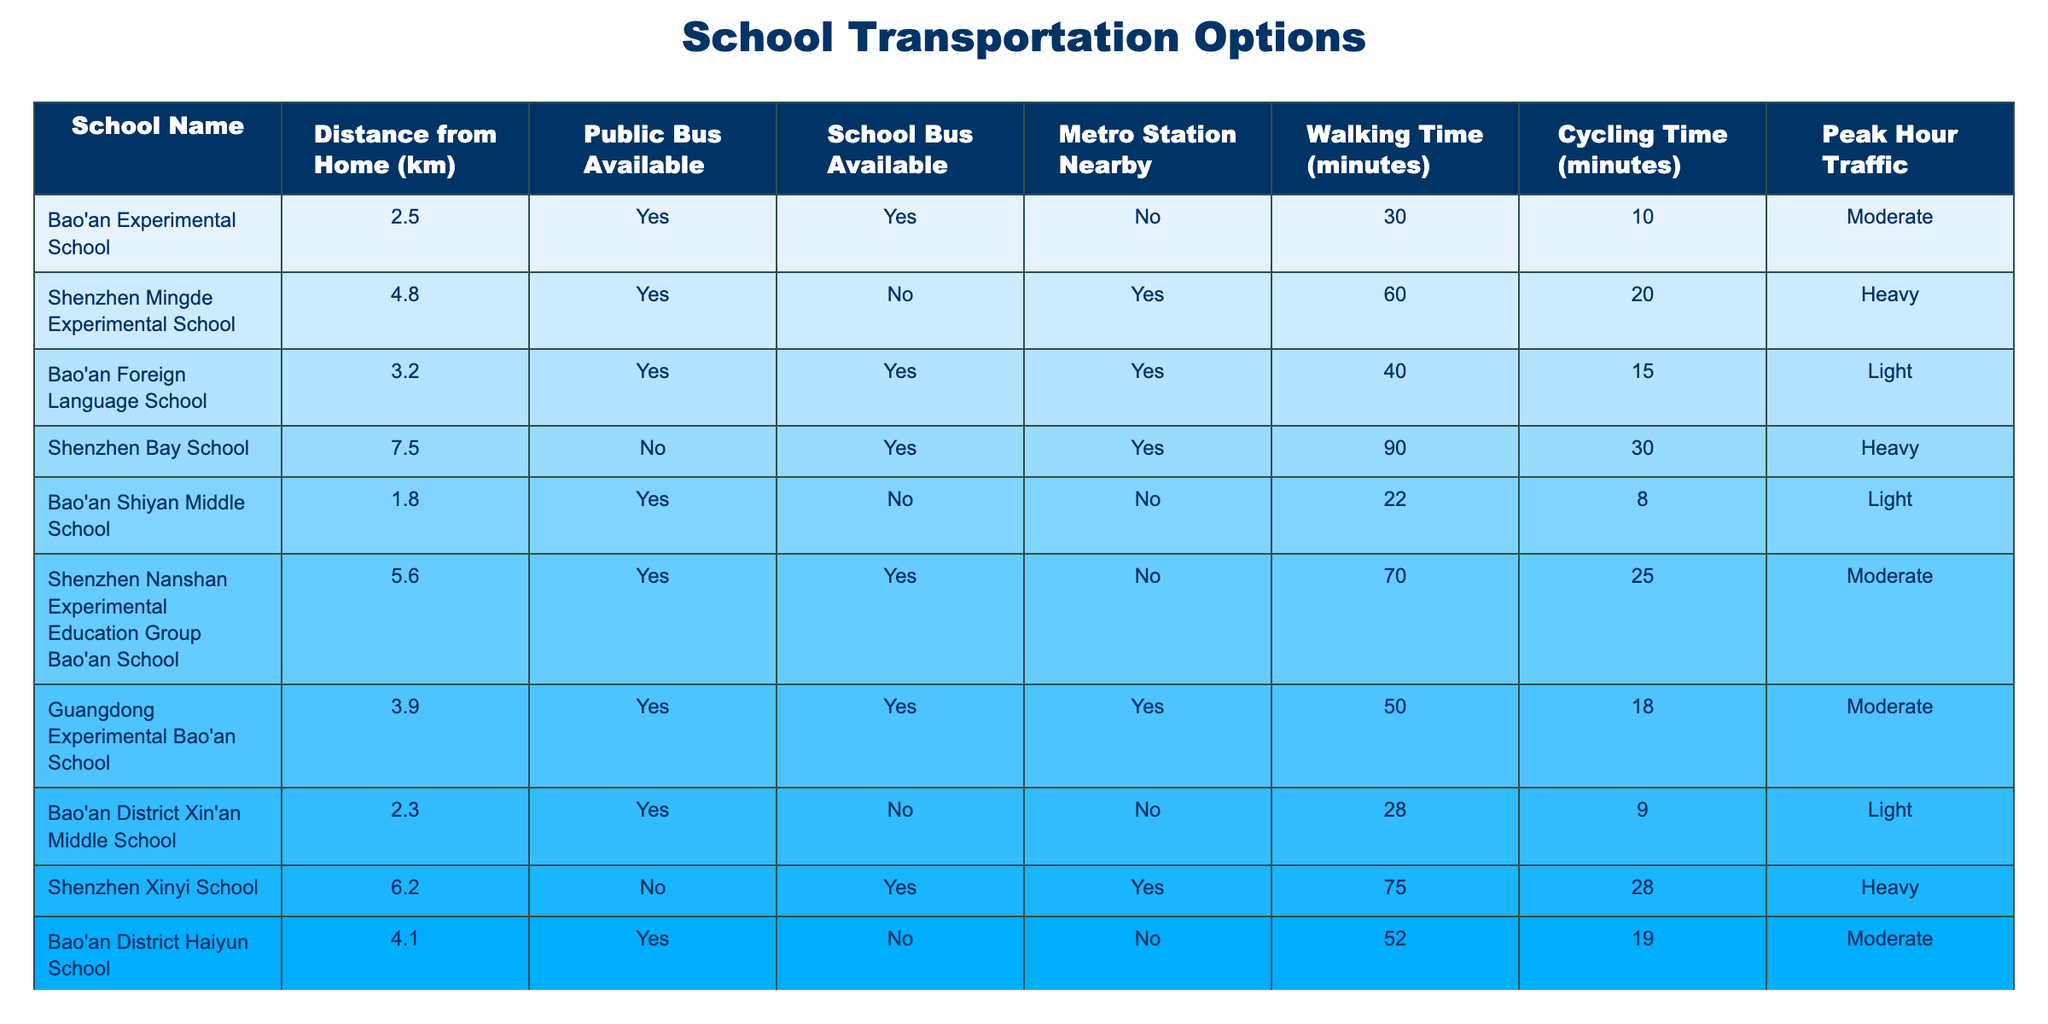What is the distance from home to Bao'an Experimental School? The distance from home to Bao'an Experimental School is listed as 2.5 km in the table.
Answer: 2.5 km Does Bao'an Shiyan Middle School have a metro station nearby? The entry for Bao'an Shiyan Middle School indicates 'No' under the metropolitan station nearby column.
Answer: No Which school has the shortest walking time from home? By comparing the walking times listed, Bao'an Shiyan Middle School has the shortest walking time of 22 minutes.
Answer: 22 minutes What transportation options are available for Guangdong Experimental Bao'an School? The table shows that there are public buses, school buses, and a metro station nearby available for Guangdong Experimental Bao'an School.
Answer: Public bus, school bus, metro station If I want to avoid heavy traffic, which schools should I consider? The schools listed with light or moderate traffic are Bao'an Foreign Language School, Bao'an Shiyan Middle School, and Bao'an District Xin'an Middle School. I recommend considering them to avoid heavy traffic.
Answer: Bao'an Foreign Language School, Bao'an Shiyan Middle School, Bao'an District Xin'an Middle School What is the average cycling time for the schools listed in the table? To find the average cycling time, we need to sum up all the cycling times: (10 + 20 + 15 + 30 + 8 + 25 + 18 + 28) = 154 for 8 entries. Thus, the average is 154/8 = 19.25 minutes.
Answer: 19.25 minutes Is there a school that offers both a public bus and school bus option nearby? Yes, the table shows that Bao'an Experimental School, Bao'an Foreign Language School, Shenzhen Nanshan Experimental Education Group Bao'an School, and Guangdong Experimental Bao'an School all have both public bus and school bus options available.
Answer: Yes What is the longest cycling time from home to school in the table? The longest cycling time in the table is for Shenzhen Xinyi School, which is 28 minutes.
Answer: 28 minutes Which school is the farthest from home? The school farthest from home is Shenzhen Bay School, with a distance of 7.5 km.
Answer: 7.5 km 